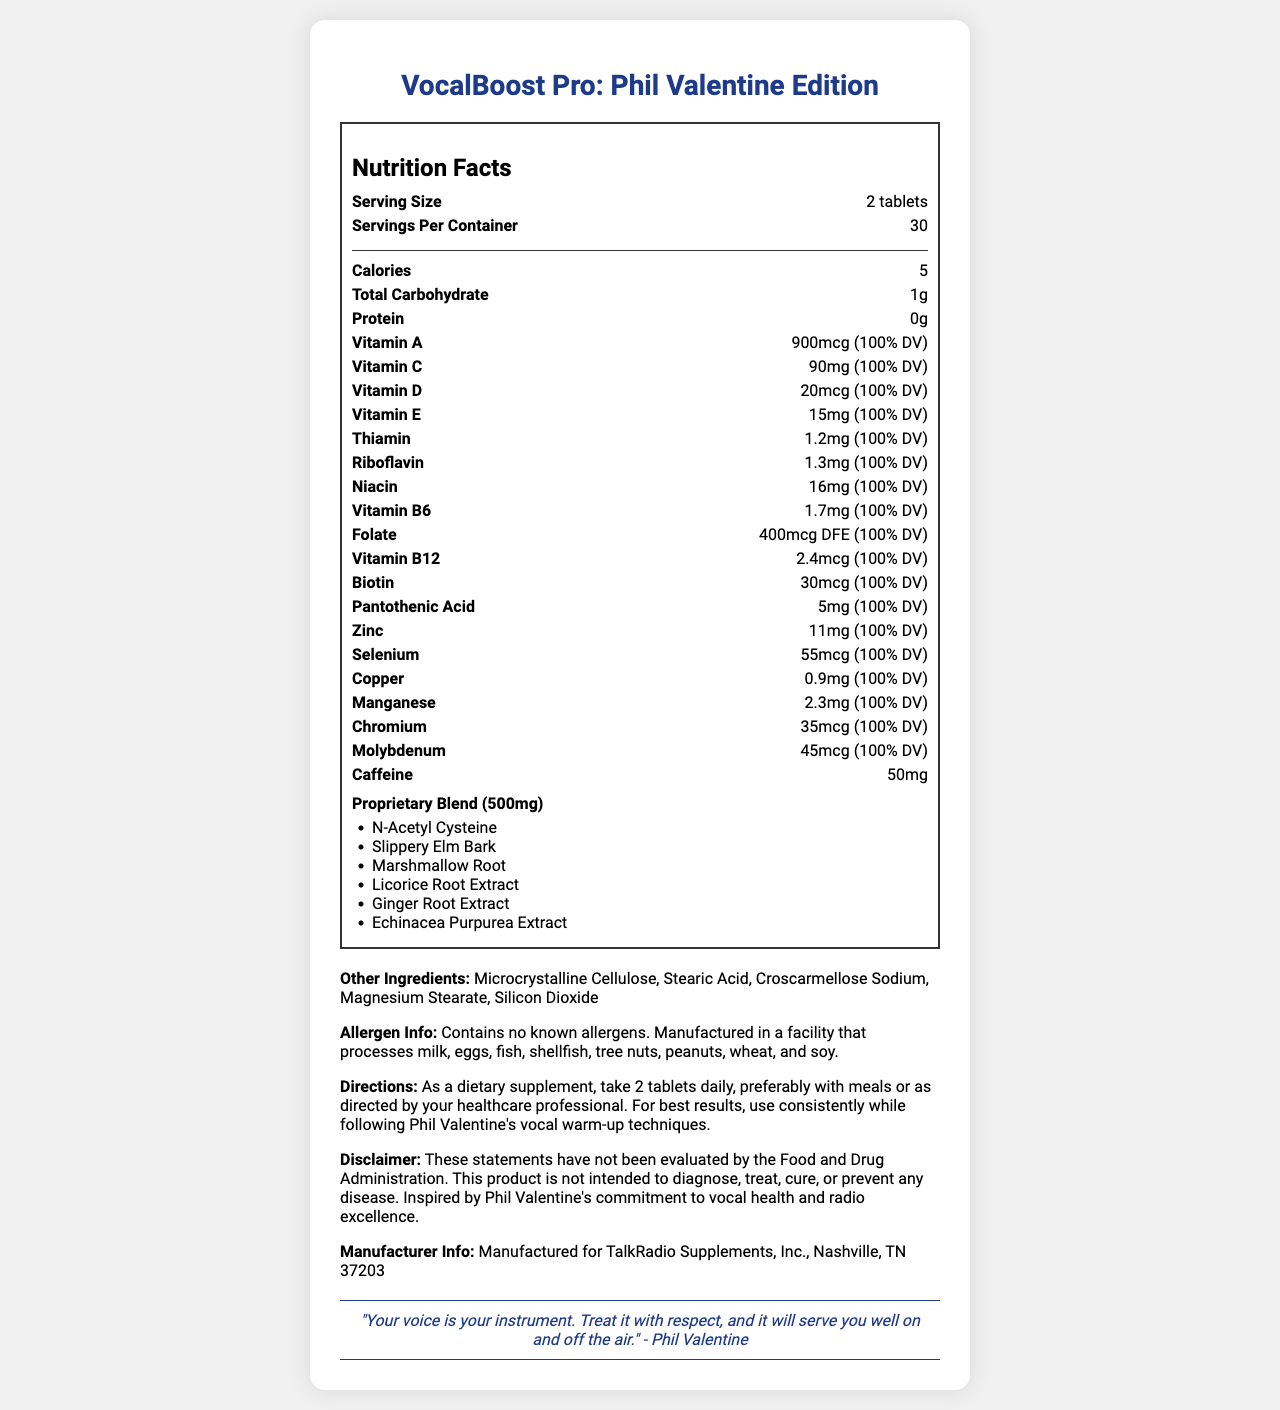what is the serving size of VocalBoost Pro: Phil Valentine Edition? The serving size information is provided under the nutrition facts section and is listed as "Serving Size: 2 tablets".
Answer: 2 tablets how many calories are in one serving of VocalBoost Pro? The nutrition facts section lists the calorie content per serving as "Calories: 5".
Answer: 5 calories which ingredient is listed in the proprietary blend? The proprietary blend section provides the list of ingredients, one of which is N-Acetyl Cysteine.
Answer: N-Acetyl Cysteine what is the daily value percentage of Vitamin C per serving? The nutrition facts indicate that the daily value percentage of Vitamin C per serving is 100%.
Answer: 100% how many servings are there per container? The nutrition facts specify the number of servings per container as 30.
Answer: 30 what is the recommended usage for VocalBoost Pro: Phil Valentine Edition? A. Take 2 tablets daily B. Take 1 tablet daily C. Take 3 tablets daily D. Take as needed The directions section specifies that the recommended usage is to take 2 tablets daily.
Answer: A. Take 2 tablets daily which of the following is NOT an ingredient in the proprietary blend? I. Licorice Root Extract II. Echinacea Purpurea Extract III. Zinc IV. Marshmallow Root Zinc is listed under the individual nutrition items and not as a part of the proprietary blend. The proprietary blend includes Licorice Root Extract, Echinacea Purpurea Extract, and Marshmallow Root.
Answer: III. Zinc does VocalBoost Pro: Phil Valentine Edition contain any known allergens? The allergen information states that the product contains no known allergens.
Answer: No summarize the main purpose of VocalBoost Pro: Phil Valentine Edition. The product is a vitamin supplement designed to support vocal health for radio hosts, inspired by Phil Valentine's commitment to vocal health.
Answer: Support vocal health for radio hosts. where is TalkRadio Supplements, Inc. located? The manufacturer information provides the location as Nashville, TN 37203.
Answer: Nashville, TN 37203 who inspired the VocalBoost Pro: Phil Valentine Edition? The product is named and inspired by Phil Valentine, his commitment to vocal health, and his excellence in radio.
Answer: Phil Valentine how much caffeine is in each serving of VocalBoost Pro? The nutrition facts section lists the caffeine content per serving as 50mg.
Answer: 50mg what percentage of the daily value does Vitamin B12 in VocalBoost Pro contribute? The document specifies that Vitamin B12 provides 100% of the daily value per serving.
Answer: 100% what is the weight of the proprietary blend in VocalBoost Pro? The proprietary blend section indicates its total weight as 500mg.
Answer: 500mg is there any iron listed in the nutrition facts of VocalBoost Pro: Phil Valentine Edition? There is no mention of iron in the nutrition facts section.
Answer: No how should one use the VocalBoost Pro tablets for best results? The directions state that for best results, one should use the tablets consistently while following Phil Valentine's vocal warm-up techniques.
Answer: Use consistently while following Phil Valentine's vocal warm-up techniques. can the statements about VocalBoost Pro's benefits be fully trusted based on FDA evaluation? The disclaimer notes that the statements have not been evaluated by the FDA and are not intended to diagnose, treat, cure, or prevent any disease.
Answer: No how many total carbohydrates per serving are in VocalBoost Pro? The nutrition facts section indicates that there is 1 gram of total carbohydrate per serving.
Answer: 1g what kind of quote is provided by Phil Valentine on the document? The quote provided by Phil Valentine is: "Your voice is your instrument. Treat it with respect, and it will serve you well on and off the air."
Answer: "Your voice is your instrument. Treat it with respect, and it will serve you well on and off the air." how much molybdenum is in each serving? The nutrition facts specify that each serving contains 45mcg of molybdenum.
Answer: 45mcg 